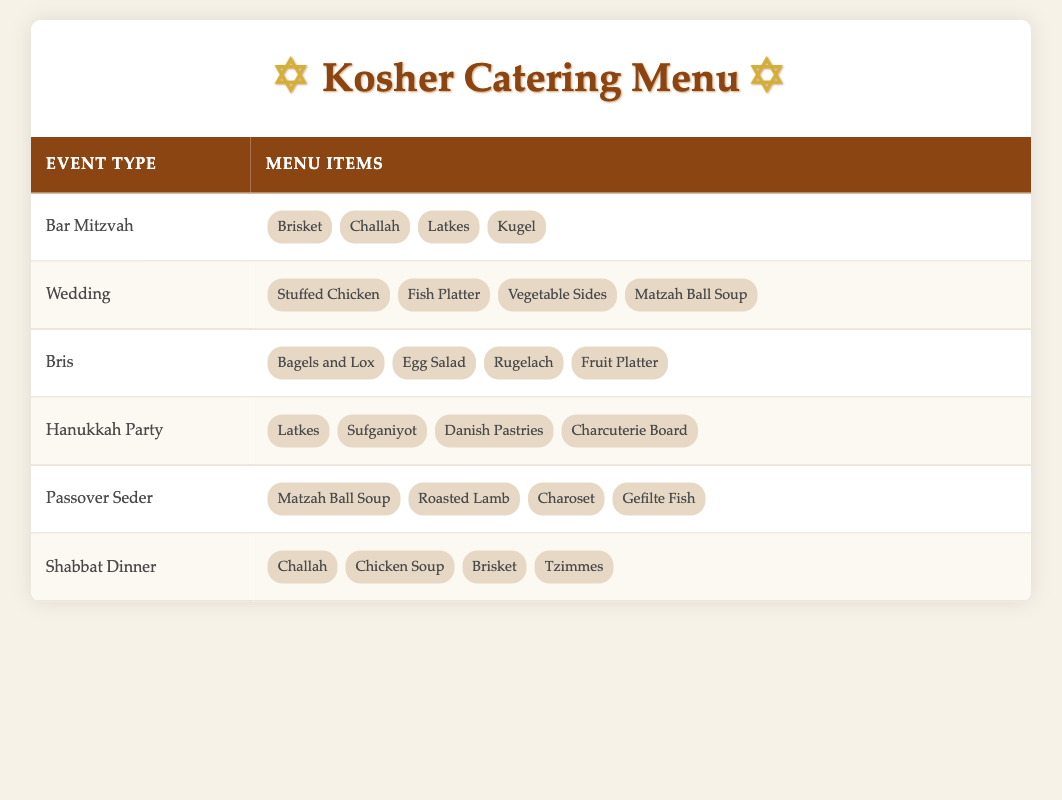What menu items are offered at a Bar Mitzvah? The table shows that the menu items for a Bar Mitzvah include Brisket, Challah, Latkes, and Kugel. Simply look at the row corresponding to Bar Mitzvah under Menu Items.
Answer: Brisket, Challah, Latkes, Kugel Is Matzah Ball Soup offered at a Passover Seder? By referring to the Passover Seder row in the Menu Items column, we see that Matzah Ball Soup is indeed listed there.
Answer: Yes How many different menu items are offered for a Wedding? The Wedding row lists four menu items: Stuffed Chicken, Fish Platter, Vegetable Sides, and Matzah Ball Soup. Counting these gives us a total of four items.
Answer: 4 Which event types offer Latkes as a menu item? Latkes are listed under both Bar Mitzvah and Hanukkah Party. To find this, I can look at the Menu Items for both event types.
Answer: Bar Mitzvah, Hanukkah Party If we count all unique menu items offered across all events, how many are there? Listing out the unique items from each event type: Brisket, Challah, Latkes, Kugel, Stuffed Chicken, Fish Platter, Vegetable Sides, Matzah Ball Soup, Bagels and Lox, Egg Salad, Rugelach, Fruit Platter, Sufganiyot, Danish Pastries, Charcuterie Board, Roasted Lamb, Charoset, Gefilte Fish, Chicken Soup, Tzimmes. There are 20 distinct items when duplicates are eliminated.
Answer: 20 Is it true that all menu items offered at a Bris are also offered at a Hanukkah Party? A comparison of the items shows that the Bris menu includes Bagels and Lox, Egg Salad, Rugelach, and Fruit Platter, while the Hanukkah Party menu has Latkes, Sufganiyot, Danish Pastries, and Charcuterie Board. Since there are no common items, the answer is no.
Answer: No For the event with the most variety in menu items, which event is it? Each event's menu items were counted: Bar Mitzvah (4), Wedding (4), Bris (4), Hanukkah Party (4), Passover Seder (4), Shabbat Dinner (4). All event types offer the same number of items, which is four. Therefore, there isn’t one with more variety.
Answer: All have the same variety What is the total number of menu items listed for Shabbat Dinner and Passover Seder combined? The Shabbat Dinner has 4 menu items (Challah, Chicken Soup, Brisket, Tzimmes) and the Passover Seder has 4 menu items (Matzah Ball Soup, Roasted Lamb, Charoset, Gefilte Fish). Adding these gives 4 + 4 = 8.
Answer: 8 Which menu item appears in the most event types? To find this, I will review each of the items across the events. Upon examination, Brisket appears in Bar Mitzvah and Shabbat Dinner. Matzah Ball Soup is in Wedding and Passover Seder. Challah is included in Bar Mitzvah and Shabbat Dinner. No item appears in more than 2 types. Thus, the answer is that multiple items tie in terms of frequency, with two occurrences each.
Answer: Multiple items tie 